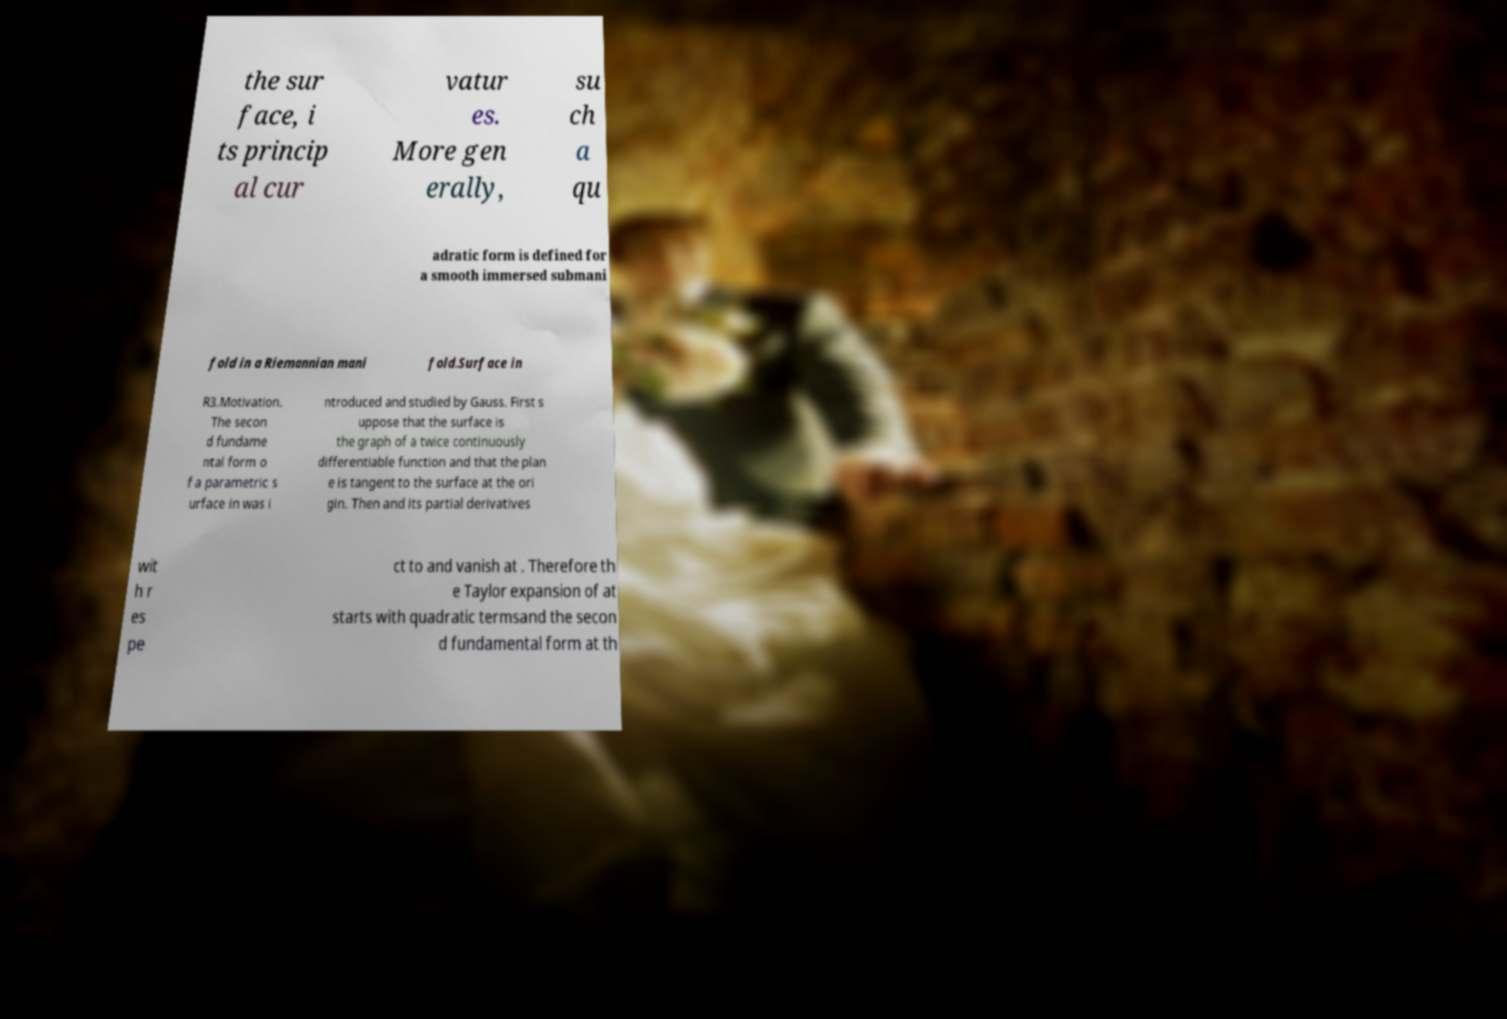Could you extract and type out the text from this image? the sur face, i ts princip al cur vatur es. More gen erally, su ch a qu adratic form is defined for a smooth immersed submani fold in a Riemannian mani fold.Surface in R3.Motivation. The secon d fundame ntal form o f a parametric s urface in was i ntroduced and studied by Gauss. First s uppose that the surface is the graph of a twice continuously differentiable function and that the plan e is tangent to the surface at the ori gin. Then and its partial derivatives wit h r es pe ct to and vanish at . Therefore th e Taylor expansion of at starts with quadratic termsand the secon d fundamental form at th 